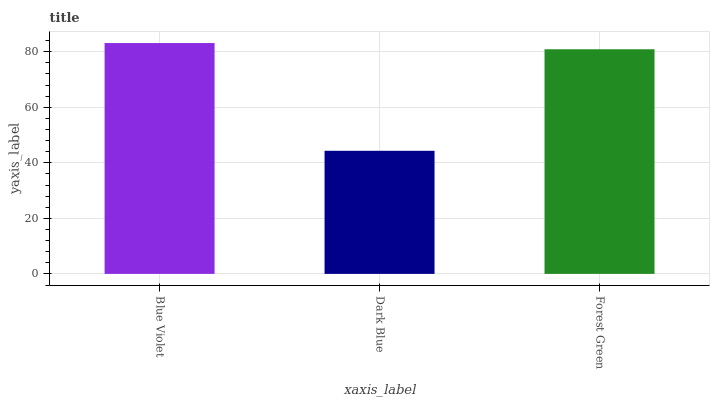Is Dark Blue the minimum?
Answer yes or no. Yes. Is Blue Violet the maximum?
Answer yes or no. Yes. Is Forest Green the minimum?
Answer yes or no. No. Is Forest Green the maximum?
Answer yes or no. No. Is Forest Green greater than Dark Blue?
Answer yes or no. Yes. Is Dark Blue less than Forest Green?
Answer yes or no. Yes. Is Dark Blue greater than Forest Green?
Answer yes or no. No. Is Forest Green less than Dark Blue?
Answer yes or no. No. Is Forest Green the high median?
Answer yes or no. Yes. Is Forest Green the low median?
Answer yes or no. Yes. Is Dark Blue the high median?
Answer yes or no. No. Is Blue Violet the low median?
Answer yes or no. No. 